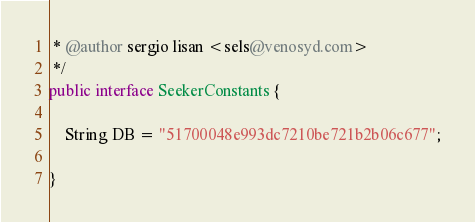Convert code to text. <code><loc_0><loc_0><loc_500><loc_500><_Java_> * @author sergio lisan <sels@venosyd.com>
 */
public interface SeekerConstants {

    String DB = "51700048e993dc7210be721b2b06c677";

}
</code> 